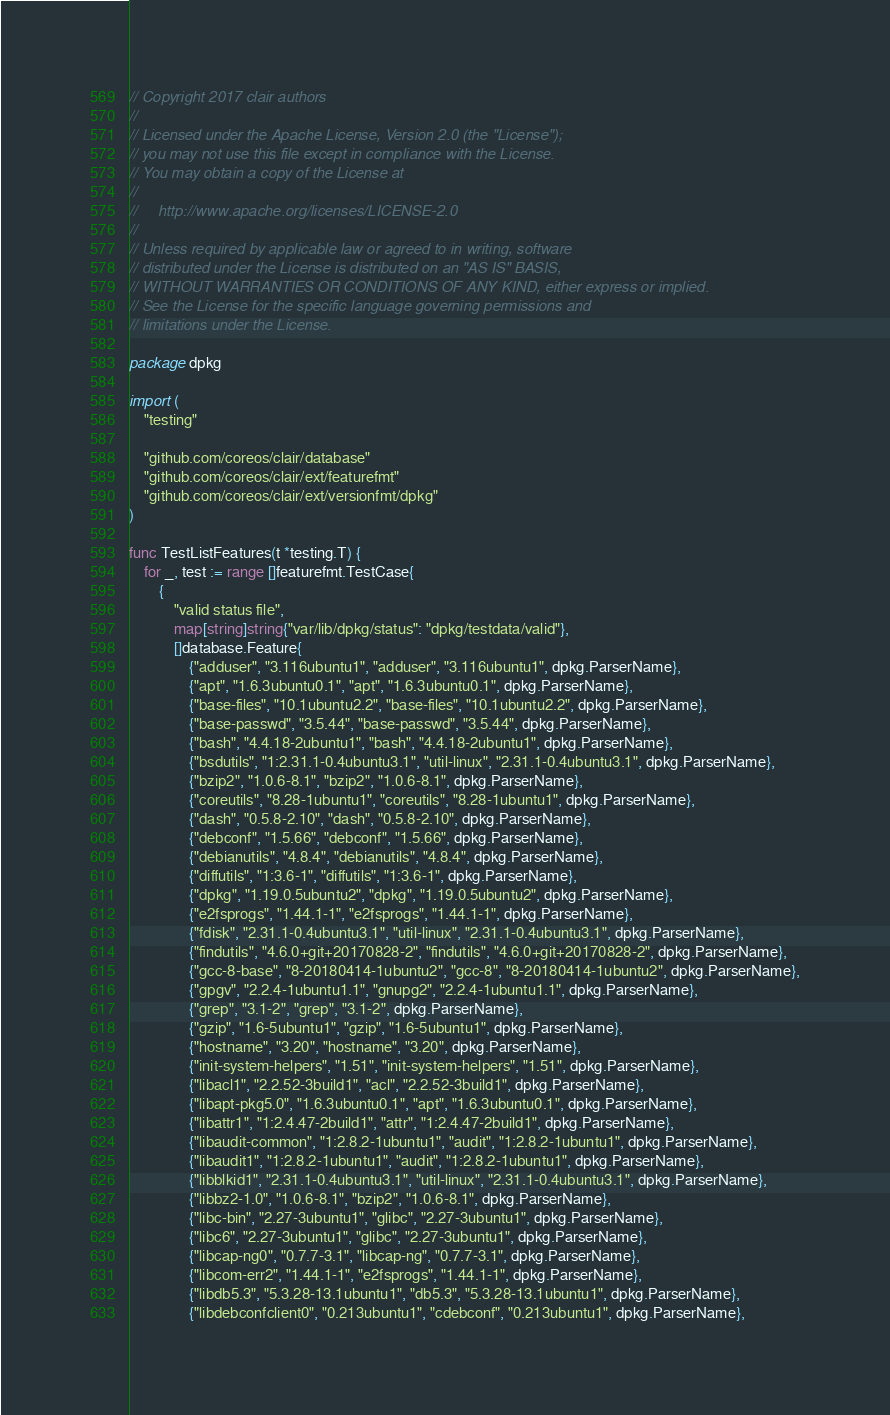Convert code to text. <code><loc_0><loc_0><loc_500><loc_500><_Go_>// Copyright 2017 clair authors
//
// Licensed under the Apache License, Version 2.0 (the "License");
// you may not use this file except in compliance with the License.
// You may obtain a copy of the License at
//
//     http://www.apache.org/licenses/LICENSE-2.0
//
// Unless required by applicable law or agreed to in writing, software
// distributed under the License is distributed on an "AS IS" BASIS,
// WITHOUT WARRANTIES OR CONDITIONS OF ANY KIND, either express or implied.
// See the License for the specific language governing permissions and
// limitations under the License.

package dpkg

import (
	"testing"

	"github.com/coreos/clair/database"
	"github.com/coreos/clair/ext/featurefmt"
	"github.com/coreos/clair/ext/versionfmt/dpkg"
)

func TestListFeatures(t *testing.T) {
	for _, test := range []featurefmt.TestCase{
		{
			"valid status file",
			map[string]string{"var/lib/dpkg/status": "dpkg/testdata/valid"},
			[]database.Feature{
				{"adduser", "3.116ubuntu1", "adduser", "3.116ubuntu1", dpkg.ParserName},
				{"apt", "1.6.3ubuntu0.1", "apt", "1.6.3ubuntu0.1", dpkg.ParserName},
				{"base-files", "10.1ubuntu2.2", "base-files", "10.1ubuntu2.2", dpkg.ParserName},
				{"base-passwd", "3.5.44", "base-passwd", "3.5.44", dpkg.ParserName},
				{"bash", "4.4.18-2ubuntu1", "bash", "4.4.18-2ubuntu1", dpkg.ParserName},
				{"bsdutils", "1:2.31.1-0.4ubuntu3.1", "util-linux", "2.31.1-0.4ubuntu3.1", dpkg.ParserName},
				{"bzip2", "1.0.6-8.1", "bzip2", "1.0.6-8.1", dpkg.ParserName},
				{"coreutils", "8.28-1ubuntu1", "coreutils", "8.28-1ubuntu1", dpkg.ParserName},
				{"dash", "0.5.8-2.10", "dash", "0.5.8-2.10", dpkg.ParserName},
				{"debconf", "1.5.66", "debconf", "1.5.66", dpkg.ParserName},
				{"debianutils", "4.8.4", "debianutils", "4.8.4", dpkg.ParserName},
				{"diffutils", "1:3.6-1", "diffutils", "1:3.6-1", dpkg.ParserName},
				{"dpkg", "1.19.0.5ubuntu2", "dpkg", "1.19.0.5ubuntu2", dpkg.ParserName},
				{"e2fsprogs", "1.44.1-1", "e2fsprogs", "1.44.1-1", dpkg.ParserName},
				{"fdisk", "2.31.1-0.4ubuntu3.1", "util-linux", "2.31.1-0.4ubuntu3.1", dpkg.ParserName},
				{"findutils", "4.6.0+git+20170828-2", "findutils", "4.6.0+git+20170828-2", dpkg.ParserName},
				{"gcc-8-base", "8-20180414-1ubuntu2", "gcc-8", "8-20180414-1ubuntu2", dpkg.ParserName},
				{"gpgv", "2.2.4-1ubuntu1.1", "gnupg2", "2.2.4-1ubuntu1.1", dpkg.ParserName},
				{"grep", "3.1-2", "grep", "3.1-2", dpkg.ParserName},
				{"gzip", "1.6-5ubuntu1", "gzip", "1.6-5ubuntu1", dpkg.ParserName},
				{"hostname", "3.20", "hostname", "3.20", dpkg.ParserName},
				{"init-system-helpers", "1.51", "init-system-helpers", "1.51", dpkg.ParserName},
				{"libacl1", "2.2.52-3build1", "acl", "2.2.52-3build1", dpkg.ParserName},
				{"libapt-pkg5.0", "1.6.3ubuntu0.1", "apt", "1.6.3ubuntu0.1", dpkg.ParserName},
				{"libattr1", "1:2.4.47-2build1", "attr", "1:2.4.47-2build1", dpkg.ParserName},
				{"libaudit-common", "1:2.8.2-1ubuntu1", "audit", "1:2.8.2-1ubuntu1", dpkg.ParserName},
				{"libaudit1", "1:2.8.2-1ubuntu1", "audit", "1:2.8.2-1ubuntu1", dpkg.ParserName},
				{"libblkid1", "2.31.1-0.4ubuntu3.1", "util-linux", "2.31.1-0.4ubuntu3.1", dpkg.ParserName},
				{"libbz2-1.0", "1.0.6-8.1", "bzip2", "1.0.6-8.1", dpkg.ParserName},
				{"libc-bin", "2.27-3ubuntu1", "glibc", "2.27-3ubuntu1", dpkg.ParserName},
				{"libc6", "2.27-3ubuntu1", "glibc", "2.27-3ubuntu1", dpkg.ParserName},
				{"libcap-ng0", "0.7.7-3.1", "libcap-ng", "0.7.7-3.1", dpkg.ParserName},
				{"libcom-err2", "1.44.1-1", "e2fsprogs", "1.44.1-1", dpkg.ParserName},
				{"libdb5.3", "5.3.28-13.1ubuntu1", "db5.3", "5.3.28-13.1ubuntu1", dpkg.ParserName},
				{"libdebconfclient0", "0.213ubuntu1", "cdebconf", "0.213ubuntu1", dpkg.ParserName},</code> 